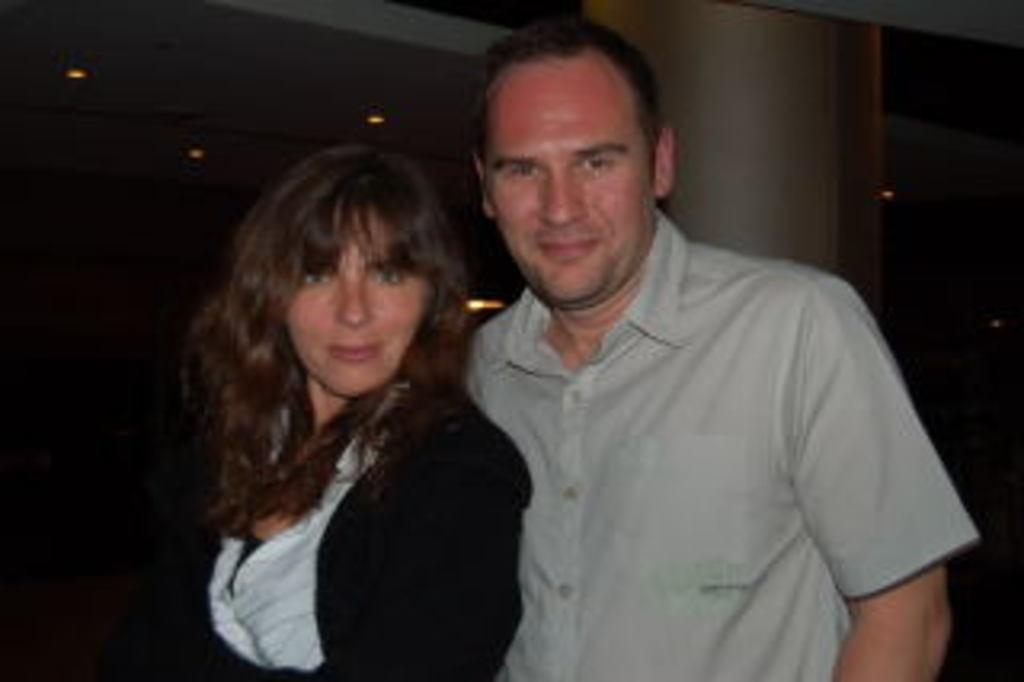How many people are present in the image? There are two people standing in the image. What is located behind the people? There is a pillar behind the people. What can be seen at the top of the image? There are ceiling lights at the top of the image. What type of pest can be seen crawling on the people's heads in the image? There are no pests visible in the image, and therefore no such activity can be observed. 